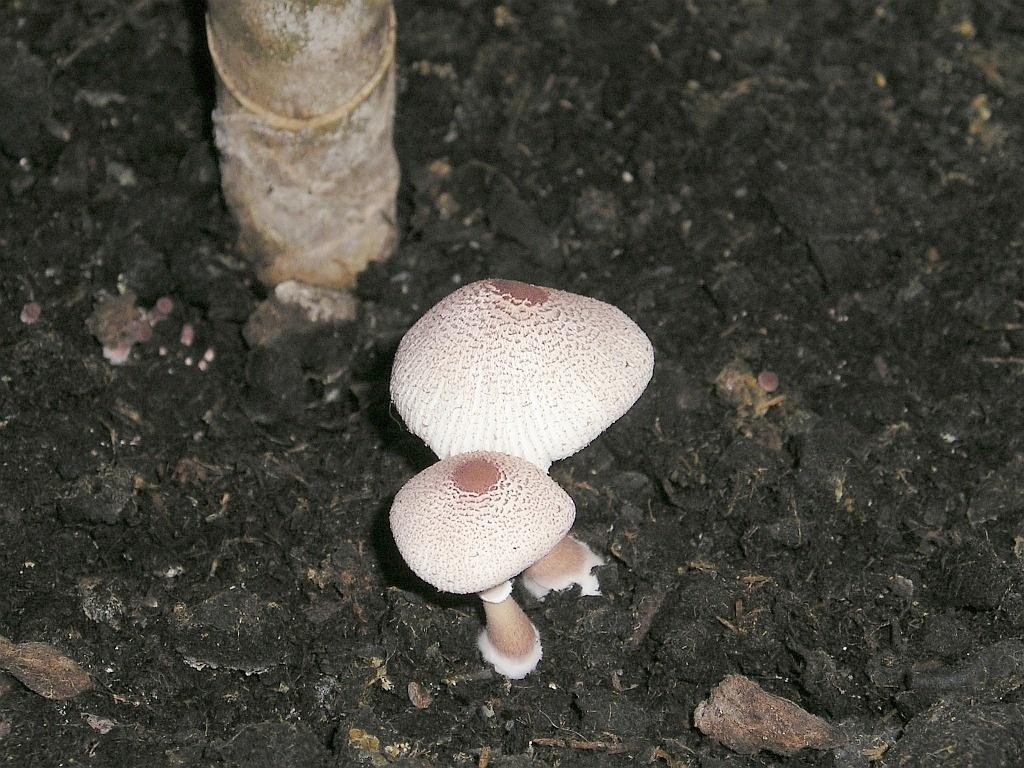What type of fungi can be seen in the image? There are mushrooms in the image. Can you describe the color scheme of the background in the image? The background of the image is in black and brown color. How does the sock contribute to the pollution in the image? There is no sock present in the image, and therefore it cannot contribute to any pollution. 